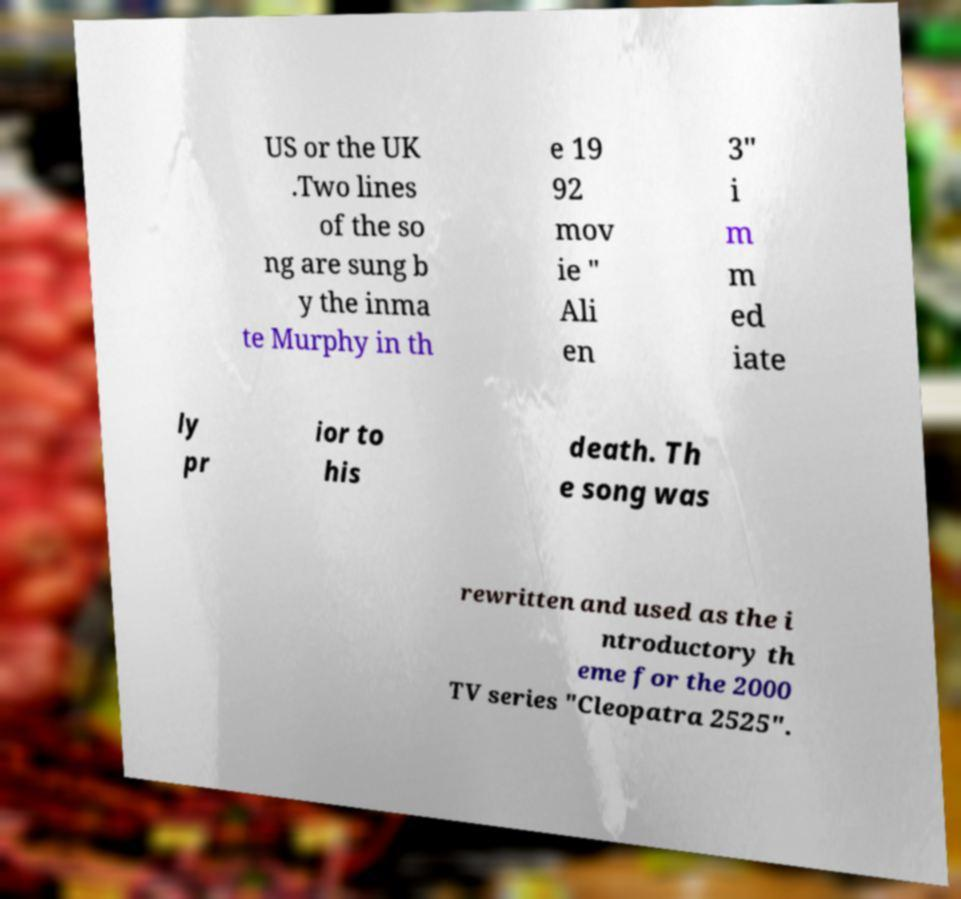There's text embedded in this image that I need extracted. Can you transcribe it verbatim? US or the UK .Two lines of the so ng are sung b y the inma te Murphy in th e 19 92 mov ie " Ali en 3" i m m ed iate ly pr ior to his death. Th e song was rewritten and used as the i ntroductory th eme for the 2000 TV series "Cleopatra 2525". 